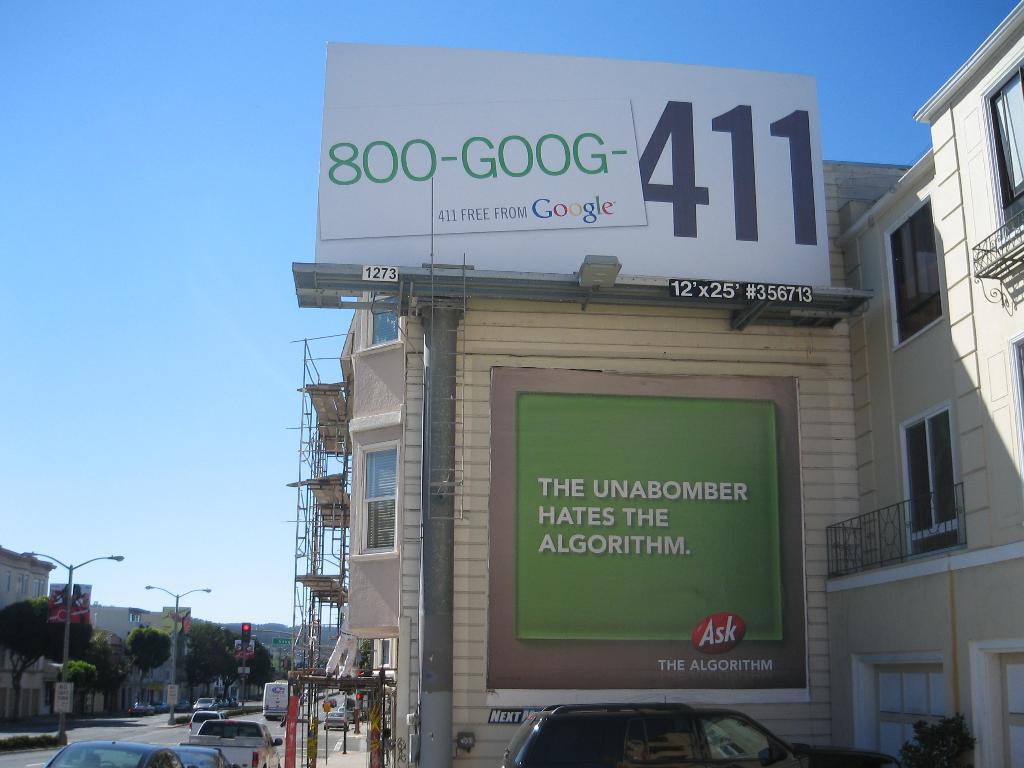Who hates the algorithm?
Offer a terse response. The unabomber. What are these advertisements for?
Your answer should be compact. Ask. What is the size of the white advertisement board?
Your answer should be compact. 12 x 25. 